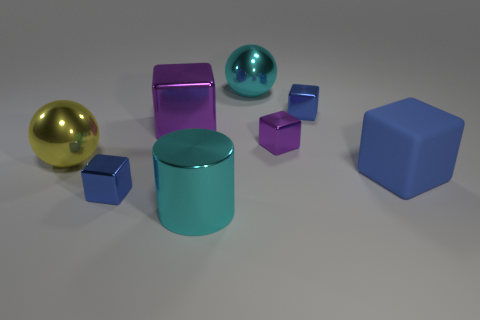How many blue blocks must be subtracted to get 1 blue blocks? 2 Subtract all tiny purple metallic cubes. How many cubes are left? 4 Subtract all blue cubes. How many cubes are left? 2 Subtract all blocks. How many objects are left? 3 Subtract all red blocks. How many green cylinders are left? 0 Add 1 big purple metallic objects. How many objects exist? 9 Subtract all yellow cubes. Subtract all red cylinders. How many cubes are left? 5 Subtract all yellow things. Subtract all big shiny spheres. How many objects are left? 5 Add 8 tiny purple objects. How many tiny purple objects are left? 9 Add 2 yellow balls. How many yellow balls exist? 3 